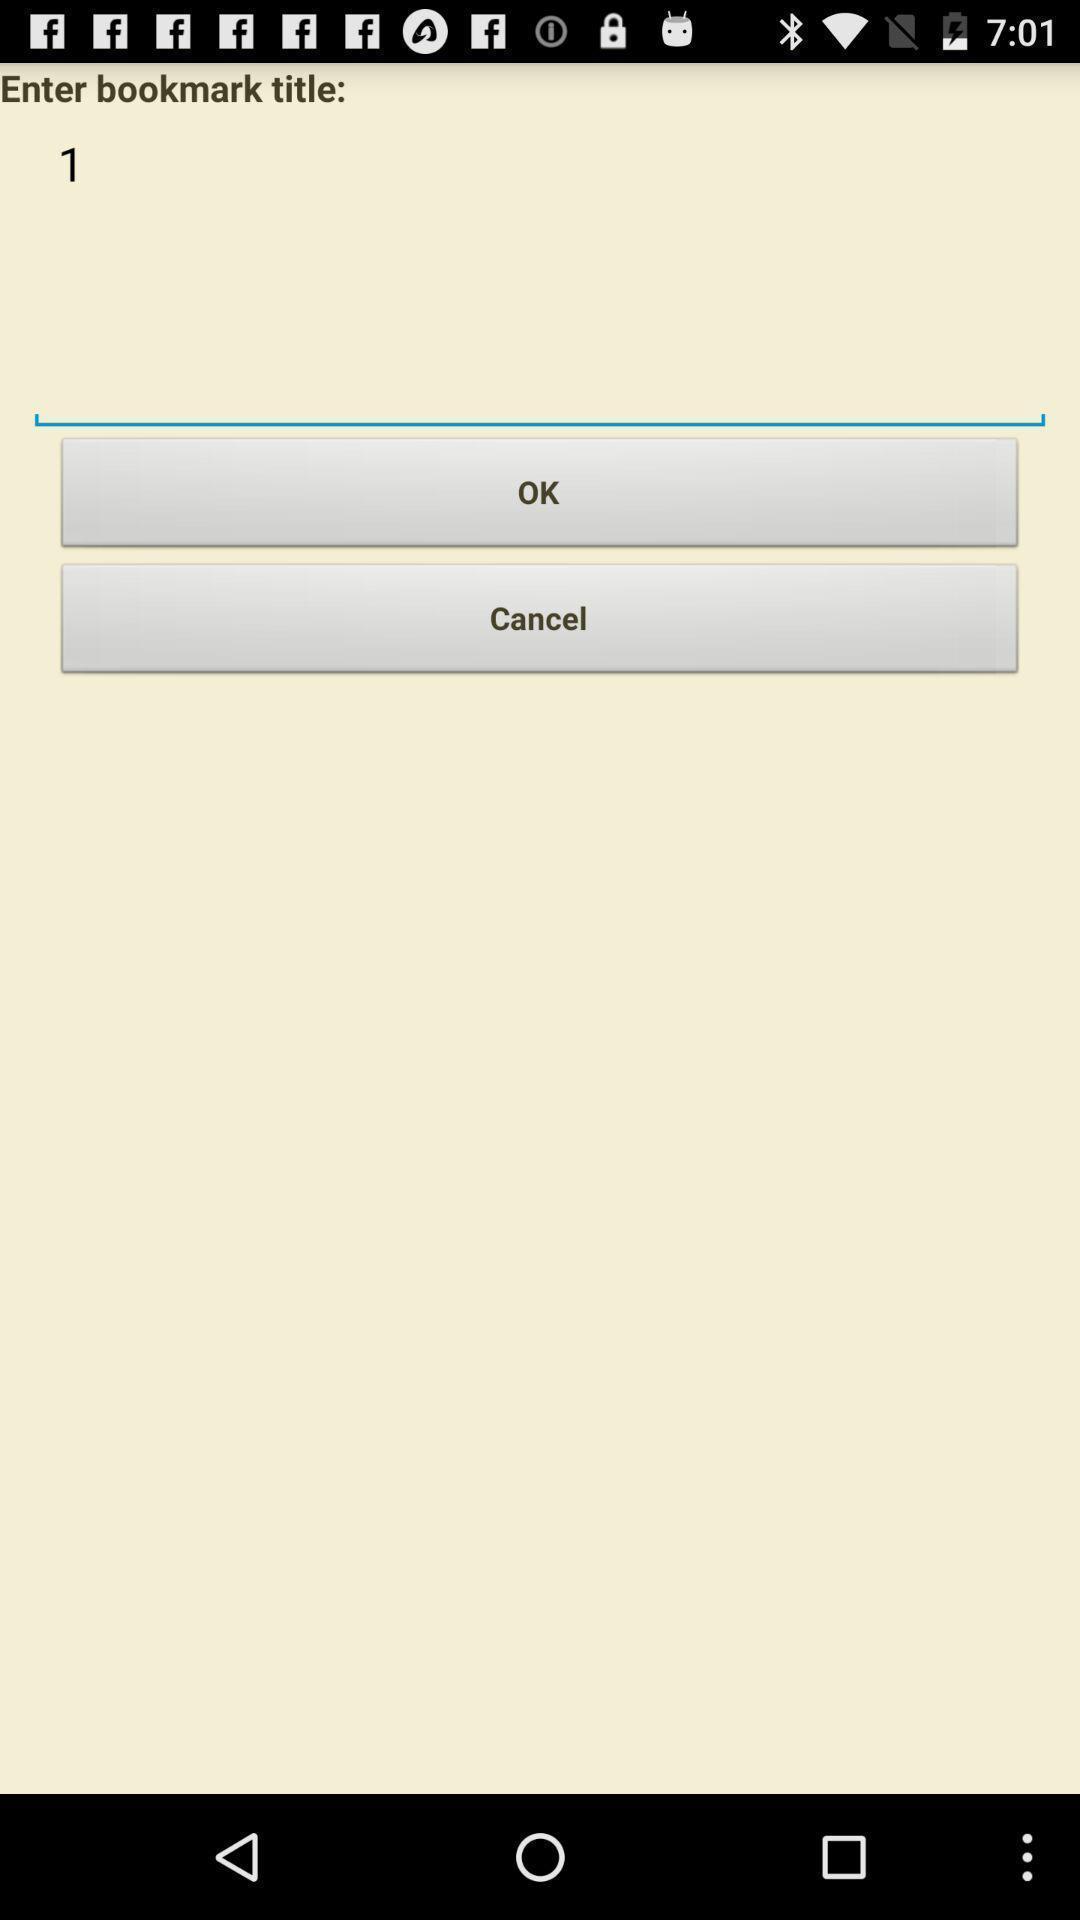What details can you identify in this image? Page displaying with option to enter title for bookmark. 